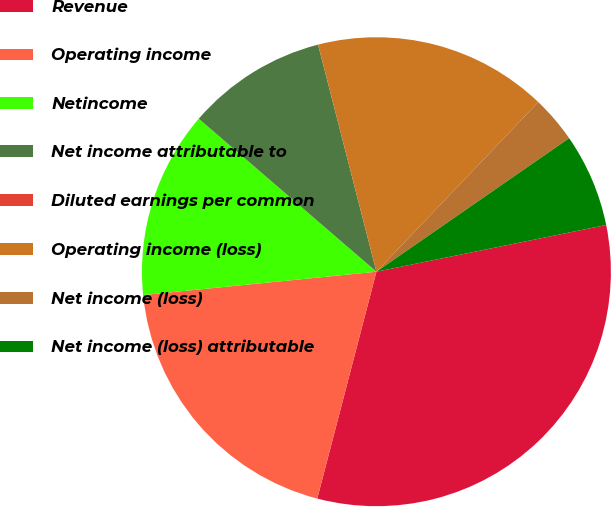Convert chart. <chart><loc_0><loc_0><loc_500><loc_500><pie_chart><fcel>Revenue<fcel>Operating income<fcel>Netincome<fcel>Net income attributable to<fcel>Diluted earnings per common<fcel>Operating income (loss)<fcel>Net income (loss)<fcel>Net income (loss) attributable<nl><fcel>32.25%<fcel>19.35%<fcel>12.9%<fcel>9.68%<fcel>0.0%<fcel>16.13%<fcel>3.23%<fcel>6.45%<nl></chart> 